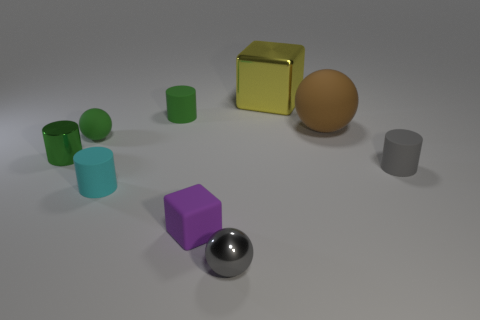Does the gray ball have the same material as the big thing in front of the tiny green rubber cylinder?
Your answer should be very brief. No. Are the gray ball right of the green ball and the tiny green cylinder behind the brown matte sphere made of the same material?
Your response must be concise. No. How many other things are there of the same size as the green matte cylinder?
Your answer should be very brief. 6. Is the shiny cylinder the same color as the small rubber ball?
Keep it short and to the point. Yes. What is the material of the small sphere that is in front of the metal thing on the left side of the purple matte block?
Give a very brief answer. Metal. What number of things are either tiny gray rubber cylinders or large gray cubes?
Ensure brevity in your answer.  1. There is a object that is in front of the yellow block and behind the big brown thing; how big is it?
Give a very brief answer. Small. What number of brown objects have the same material as the tiny green sphere?
Ensure brevity in your answer.  1. There is a big sphere that is made of the same material as the tiny gray cylinder; what is its color?
Keep it short and to the point. Brown. There is a matte thing that is to the left of the tiny cyan rubber object; is it the same color as the tiny metal cylinder?
Your response must be concise. Yes. 